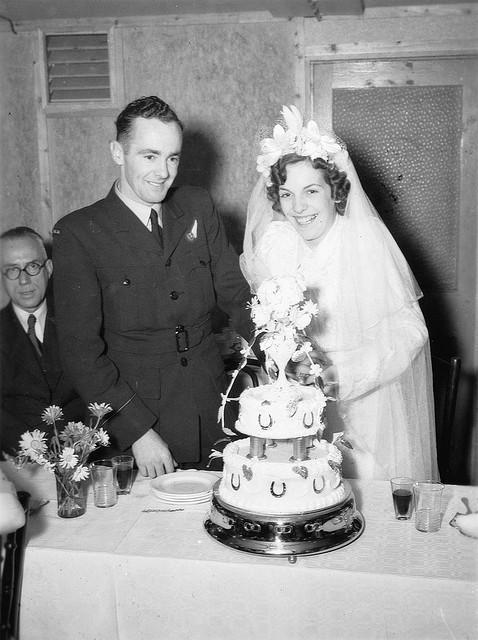How many ladies faces are there?
Give a very brief answer. 1. How many cakes are there?
Give a very brief answer. 2. How many people are in the photo?
Give a very brief answer. 3. 